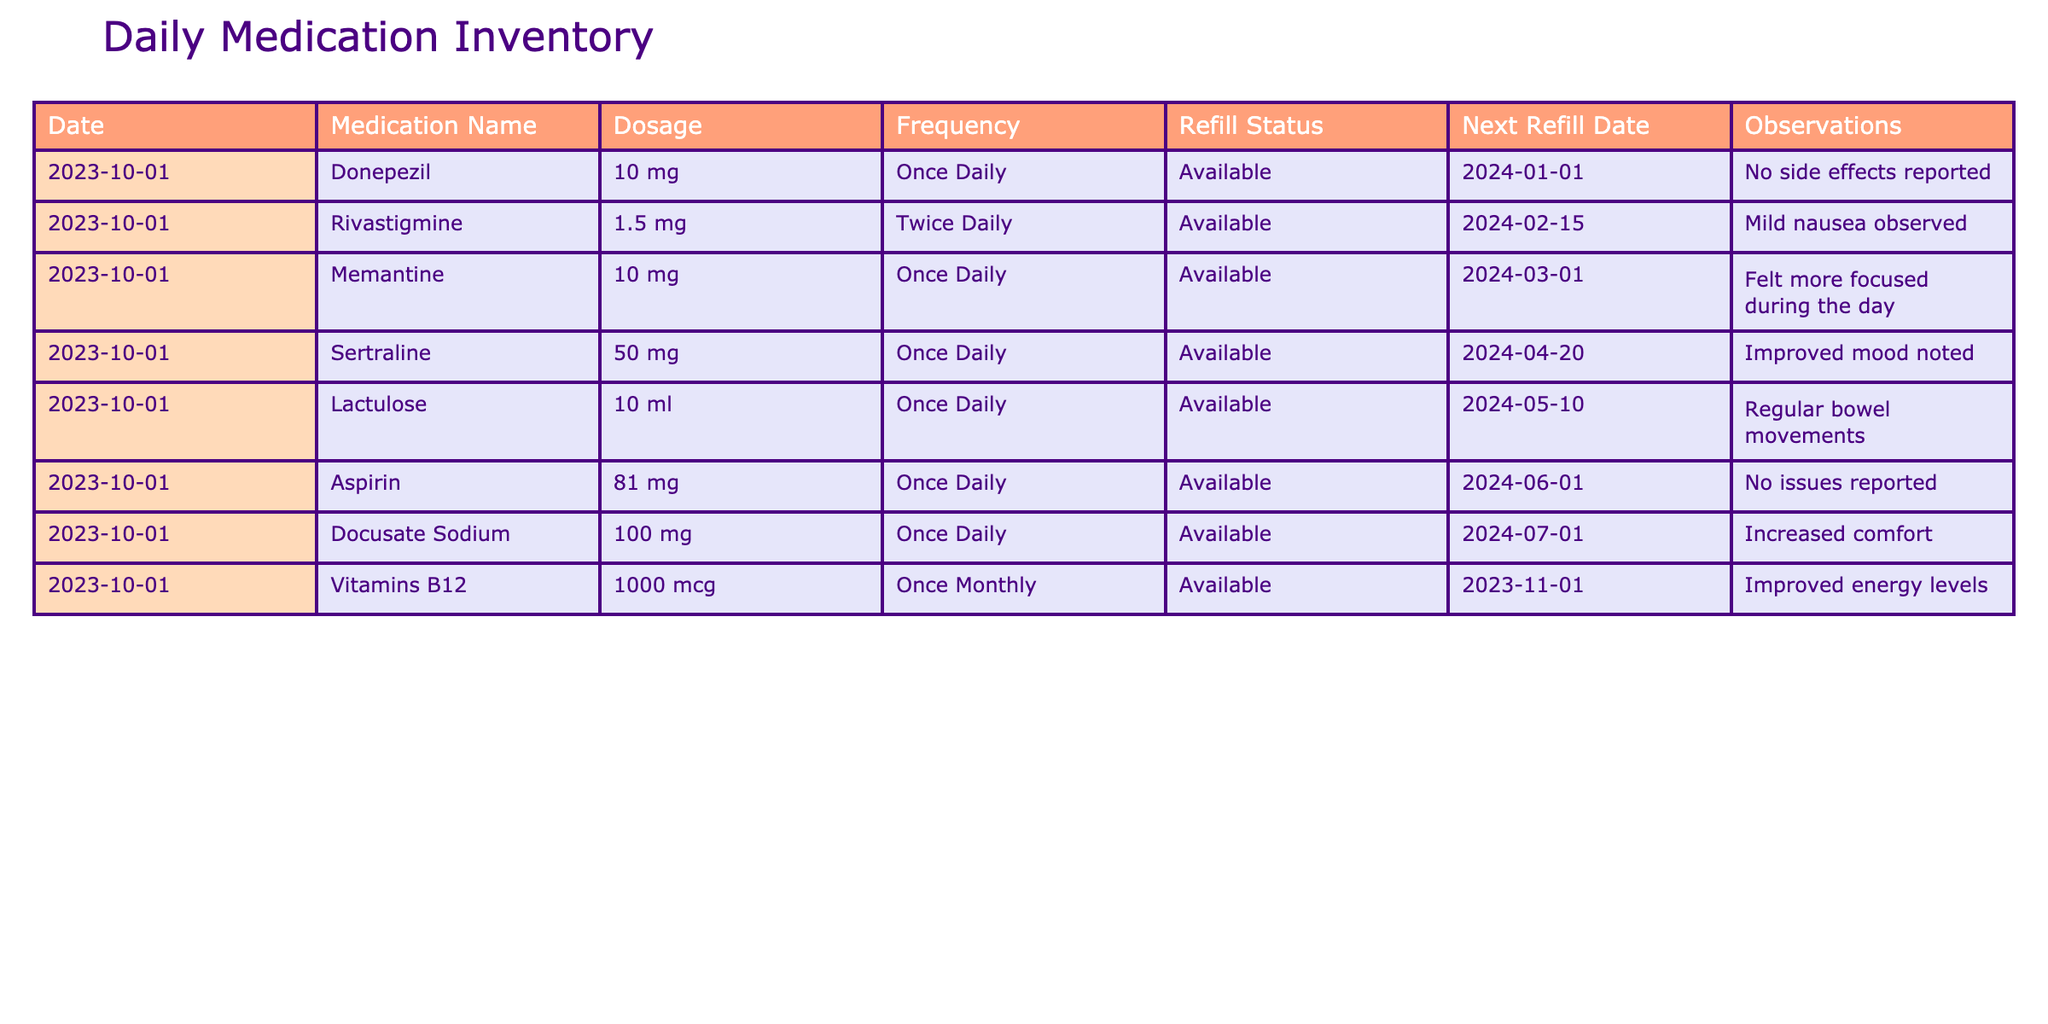What medications are available to be refilled next? To answer this question, we can scan the "Refill Status" column for medications listed as "Available". Then, we need to check the "Next Refill Date" for those medications, which all show valid future dates. Therefore, all medications listed are available for refills.
Answer: Donepezil, Rivastigmine, Memantine, Sertraline, Lactulose, Aspirin, Docusate Sodium, Vitamins B12 How many medications are taken more than once daily? Looking at the "Frequency" column, we only find one medication listed with a frequency greater than once daily, which is Rivastigmine taken twice daily. Thus, we only count this specific case.
Answer: 1 Is there any medication reported with side effects? By reviewing the "Observations" column, only Rivastigmine has mild nausea reported among all the medications. Therefore, we check if there are any side effects mentioned at all, confirming Rivastigmine's case.
Answer: Yes What is the total daily dosage for Donepezil and Rivastigmine? To find the total daily dosage, we first locate each medication's dosage. Donepezil is 10 mg taken once daily, and Rivastigmine is 1.5 mg taken twice daily. We calculate Rivastigmine's daily dosage as 1.5 mg x 2 = 3 mg. Now, we sum them both: 10 mg (Donepezil) + 3 mg (Rivastigmine) = 13 mg total.
Answer: 13 mg Which medication had an observation related to mood improvement, and what was it? Looking at the "Observations" column for any mentions of mood improvement, we note that Sertraline has been reported with improved mood noted. Thus, we identify Sertraline as the medication in question with its observation.
Answer: Sertraline, improved mood noted What is the frequency of Docusate Sodium? We can directly refer to the "Frequency" column where Docusate Sodium is listed. It shows the frequency of dosage clearly.
Answer: Once Daily 